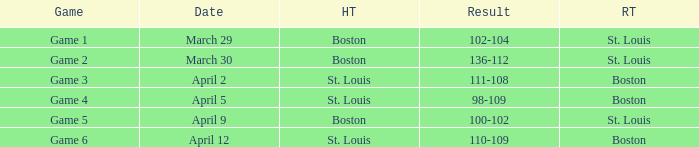On april 12, what is the game number for the match with st. louis playing at home? Game 6. 